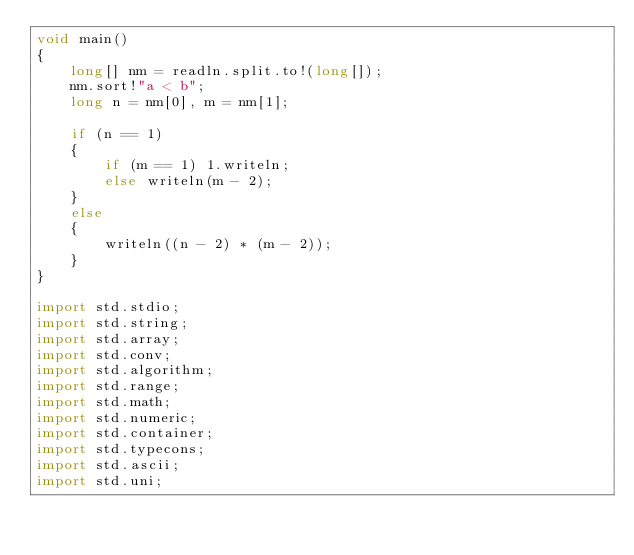Convert code to text. <code><loc_0><loc_0><loc_500><loc_500><_D_>void main()
{
    long[] nm = readln.split.to!(long[]);
    nm.sort!"a < b";
    long n = nm[0], m = nm[1];

    if (n == 1)
    {
        if (m == 1) 1.writeln;
        else writeln(m - 2);
    }
    else
    {
        writeln((n - 2) * (m - 2));
    }
}

import std.stdio;
import std.string;
import std.array;
import std.conv;
import std.algorithm;
import std.range;
import std.math;
import std.numeric;
import std.container;
import std.typecons;
import std.ascii;
import std.uni;</code> 